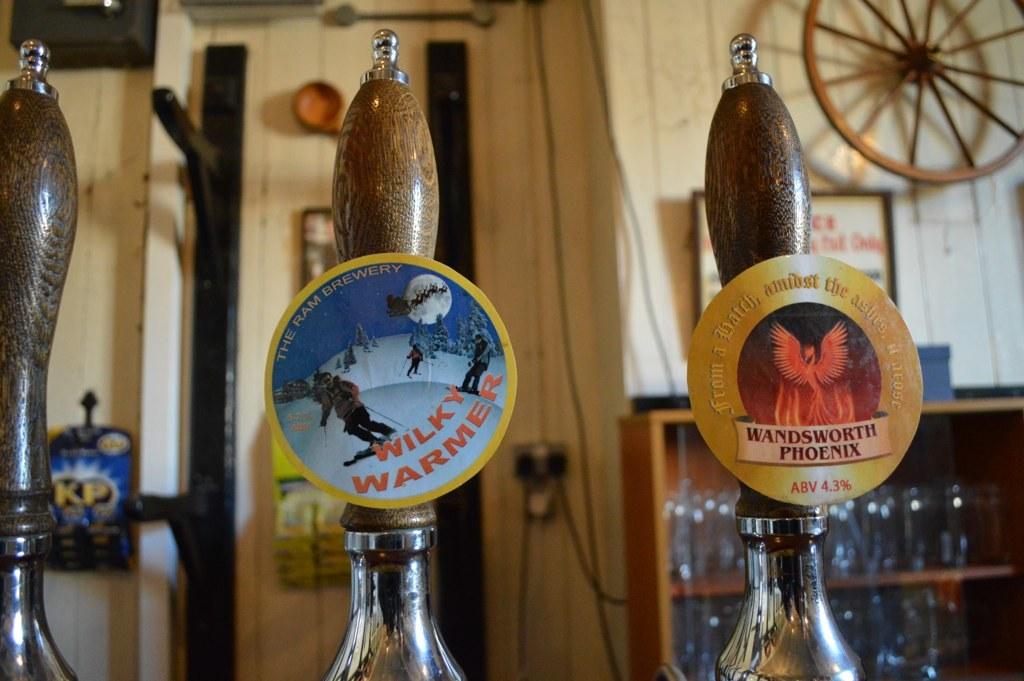What beer is on the far right tap?
Make the answer very short. Wandsworth phoenix. What brand of beer is severed in the middle tap?
Keep it short and to the point. Wilky warmer. 